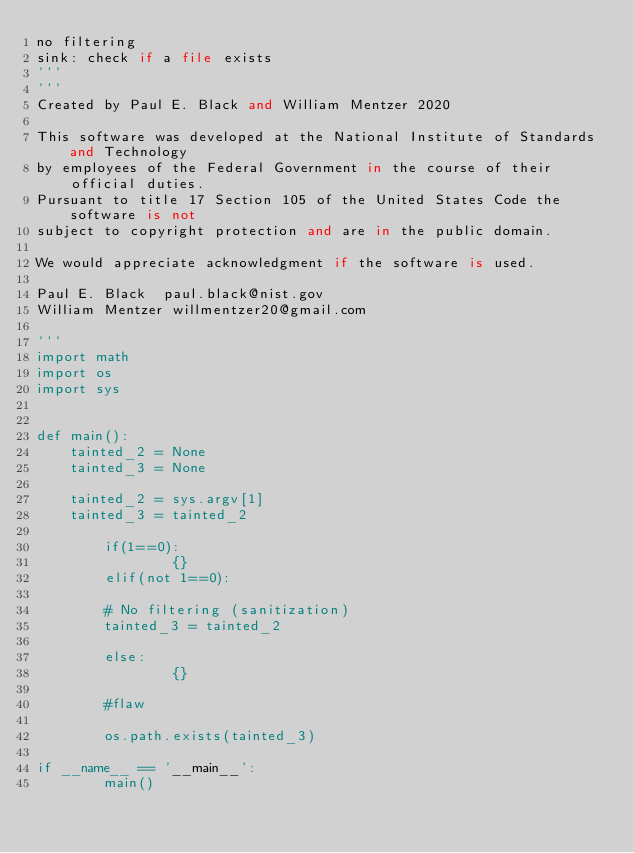<code> <loc_0><loc_0><loc_500><loc_500><_Python_>no filtering
sink: check if a file exists
'''
'''
Created by Paul E. Black and William Mentzer 2020

This software was developed at the National Institute of Standards and Technology
by employees of the Federal Government in the course of their official duties.
Pursuant to title 17 Section 105 of the United States Code the software is not
subject to copyright protection and are in the public domain.

We would appreciate acknowledgment if the software is used.

Paul E. Black  paul.black@nist.gov
William Mentzer willmentzer20@gmail.com

'''
import math
import os
import sys


def main():
    tainted_2 = None
    tainted_3 = None

    tainted_2 = sys.argv[1]
    tainted_3 = tainted_2

        if(1==0):
                {}
        elif(not 1==0):
                
        # No filtering (sanitization)
        tainted_3 = tainted_2
            
        else:
                {}

        #flaw

        os.path.exists(tainted_3)

if __name__ == '__main__':
        main()</code> 